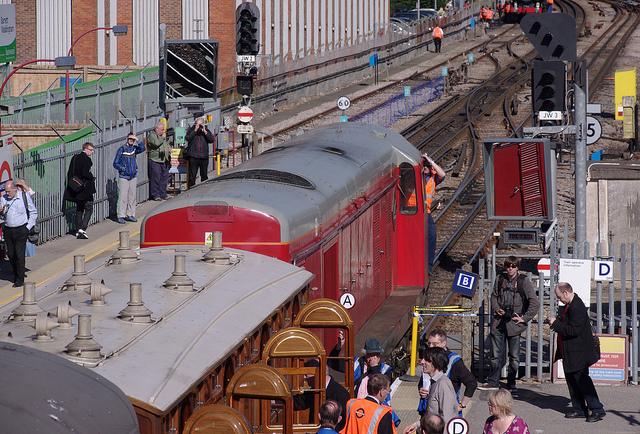What is the furthest visible train platform number?
Concise answer only. 60. What mode of transportation is this?
Answer briefly. Train. Is this a United States location?
Keep it brief. No. Is this train brand new?
Be succinct. No. What train platform numbers are shown?
Quick response, please. 0. 